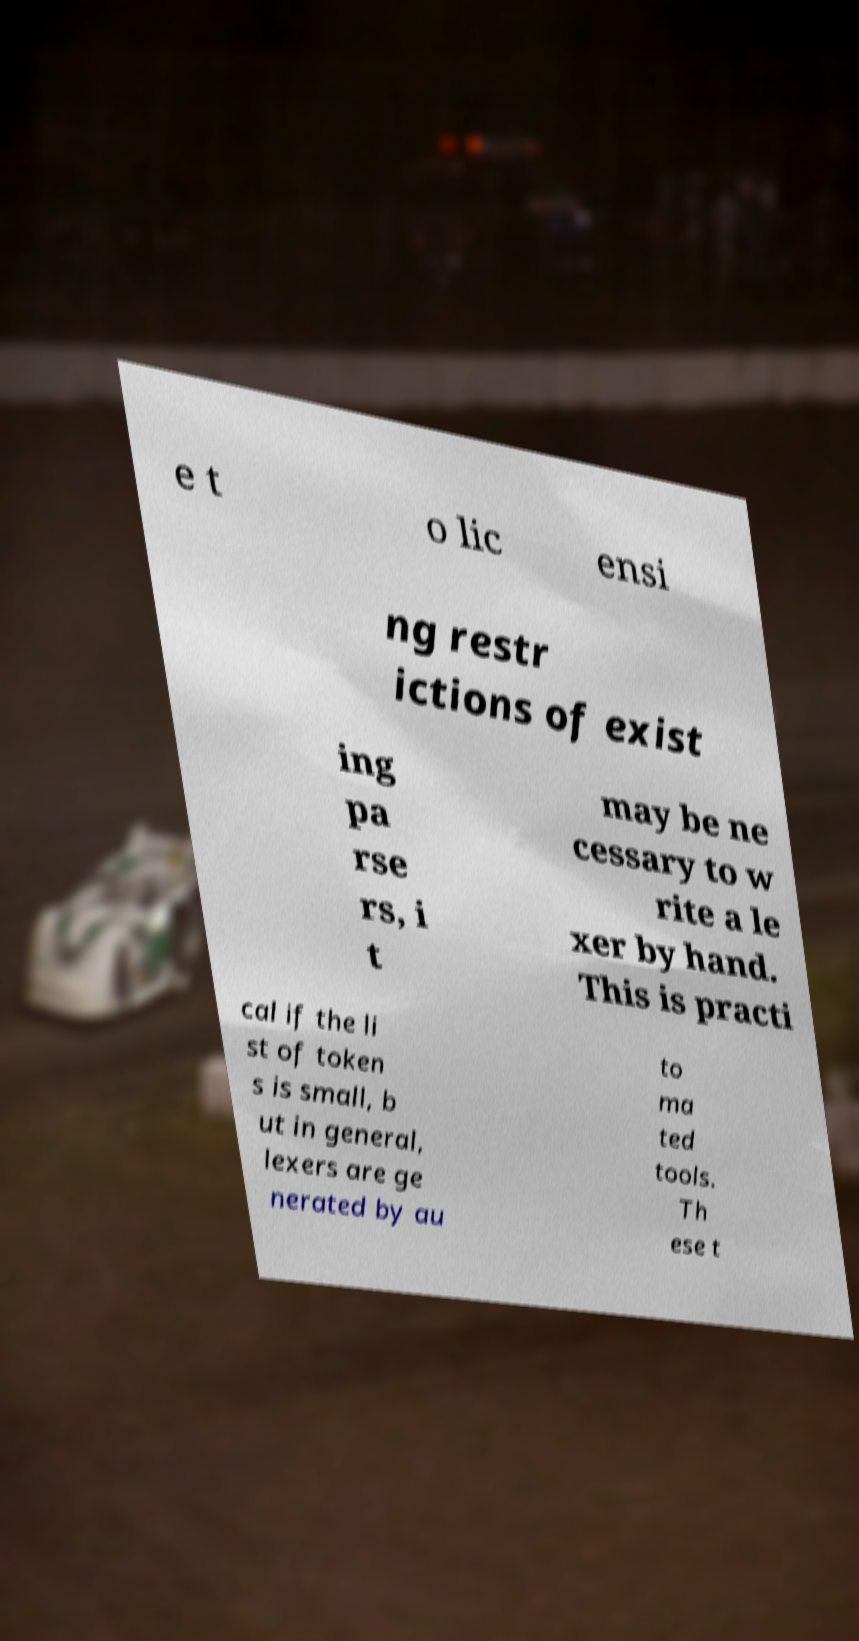Please read and relay the text visible in this image. What does it say? e t o lic ensi ng restr ictions of exist ing pa rse rs, i t may be ne cessary to w rite a le xer by hand. This is practi cal if the li st of token s is small, b ut in general, lexers are ge nerated by au to ma ted tools. Th ese t 